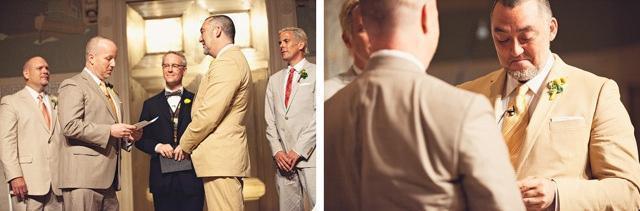How many people are there?
Give a very brief answer. 7. How many sandwiches with orange paste are in the picture?
Give a very brief answer. 0. 